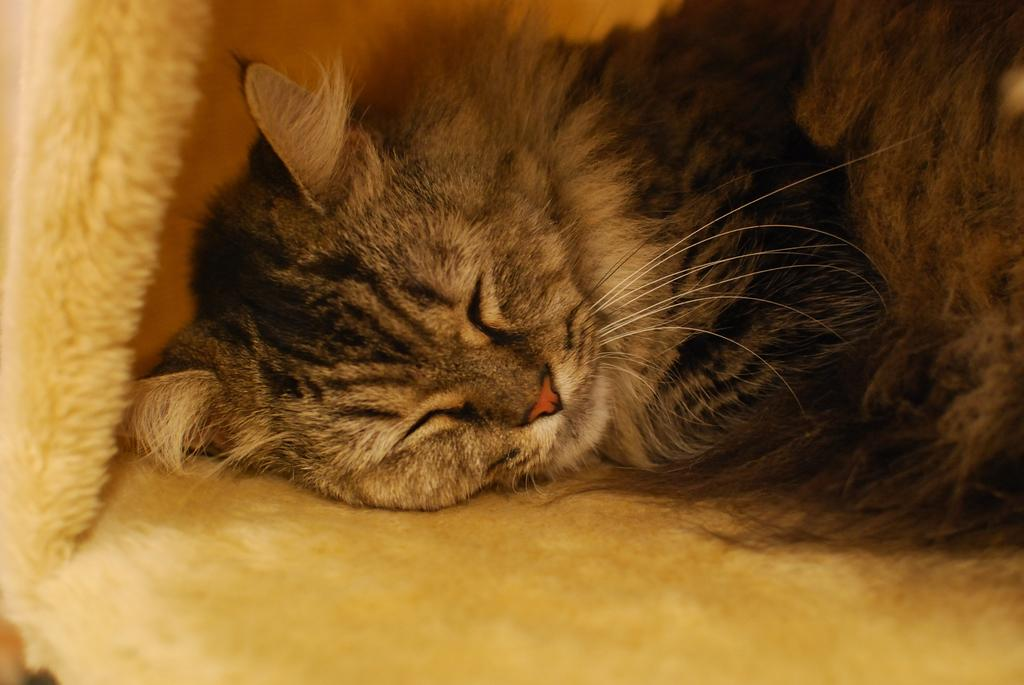What animal is present in the image? There is a cat in the image. What color combination is the cat in? The cat is in black and white color combination. What is the cat doing in the image? The cat is sleeping. Can you describe any other objects or elements in the image? There is a yellow cloth in the image. What type of destruction is the cat causing in the image? There is no destruction present in the image; the cat is sleeping peacefully. What color is the cat's collar in the image? There is no collar visible on the cat in the image. 